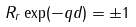Convert formula to latex. <formula><loc_0><loc_0><loc_500><loc_500>R _ { r } \exp ( - q d ) = \pm 1</formula> 